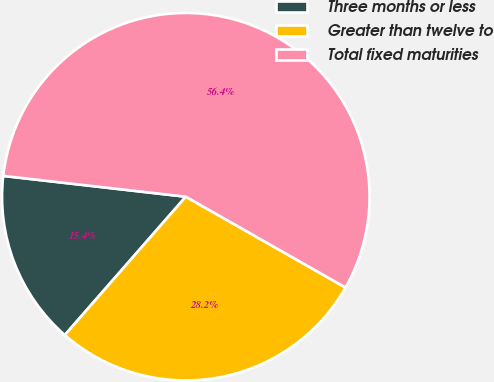Convert chart to OTSL. <chart><loc_0><loc_0><loc_500><loc_500><pie_chart><fcel>Three months or less<fcel>Greater than twelve to<fcel>Total fixed maturities<nl><fcel>15.37%<fcel>28.21%<fcel>56.42%<nl></chart> 